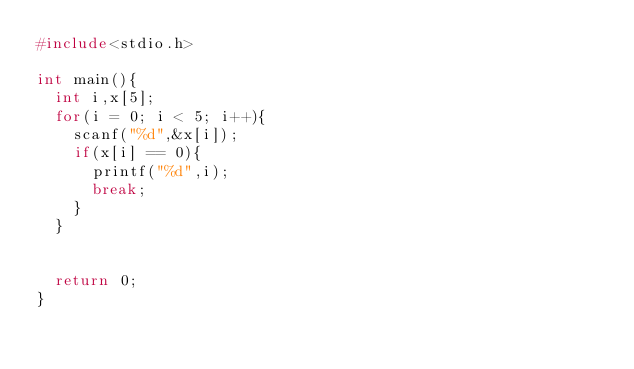Convert code to text. <code><loc_0><loc_0><loc_500><loc_500><_C_>#include<stdio.h>

int main(){
	int i,x[5];
	for(i = 0; i < 5; i++){
		scanf("%d",&x[i]);
		if(x[i] == 0){
			printf("%d",i);
			break;
		}
	}


	return 0;
}
</code> 